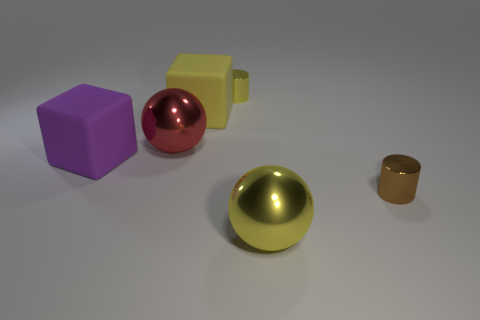Add 3 small yellow objects. How many objects exist? 9 Subtract all cubes. How many objects are left? 4 Subtract 0 brown cubes. How many objects are left? 6 Subtract 2 cylinders. How many cylinders are left? 0 Subtract all red cylinders. Subtract all blue cubes. How many cylinders are left? 2 Subtract all tiny yellow metallic cylinders. Subtract all large yellow spheres. How many objects are left? 4 Add 2 red objects. How many red objects are left? 3 Add 2 tiny cyan matte cylinders. How many tiny cyan matte cylinders exist? 2 